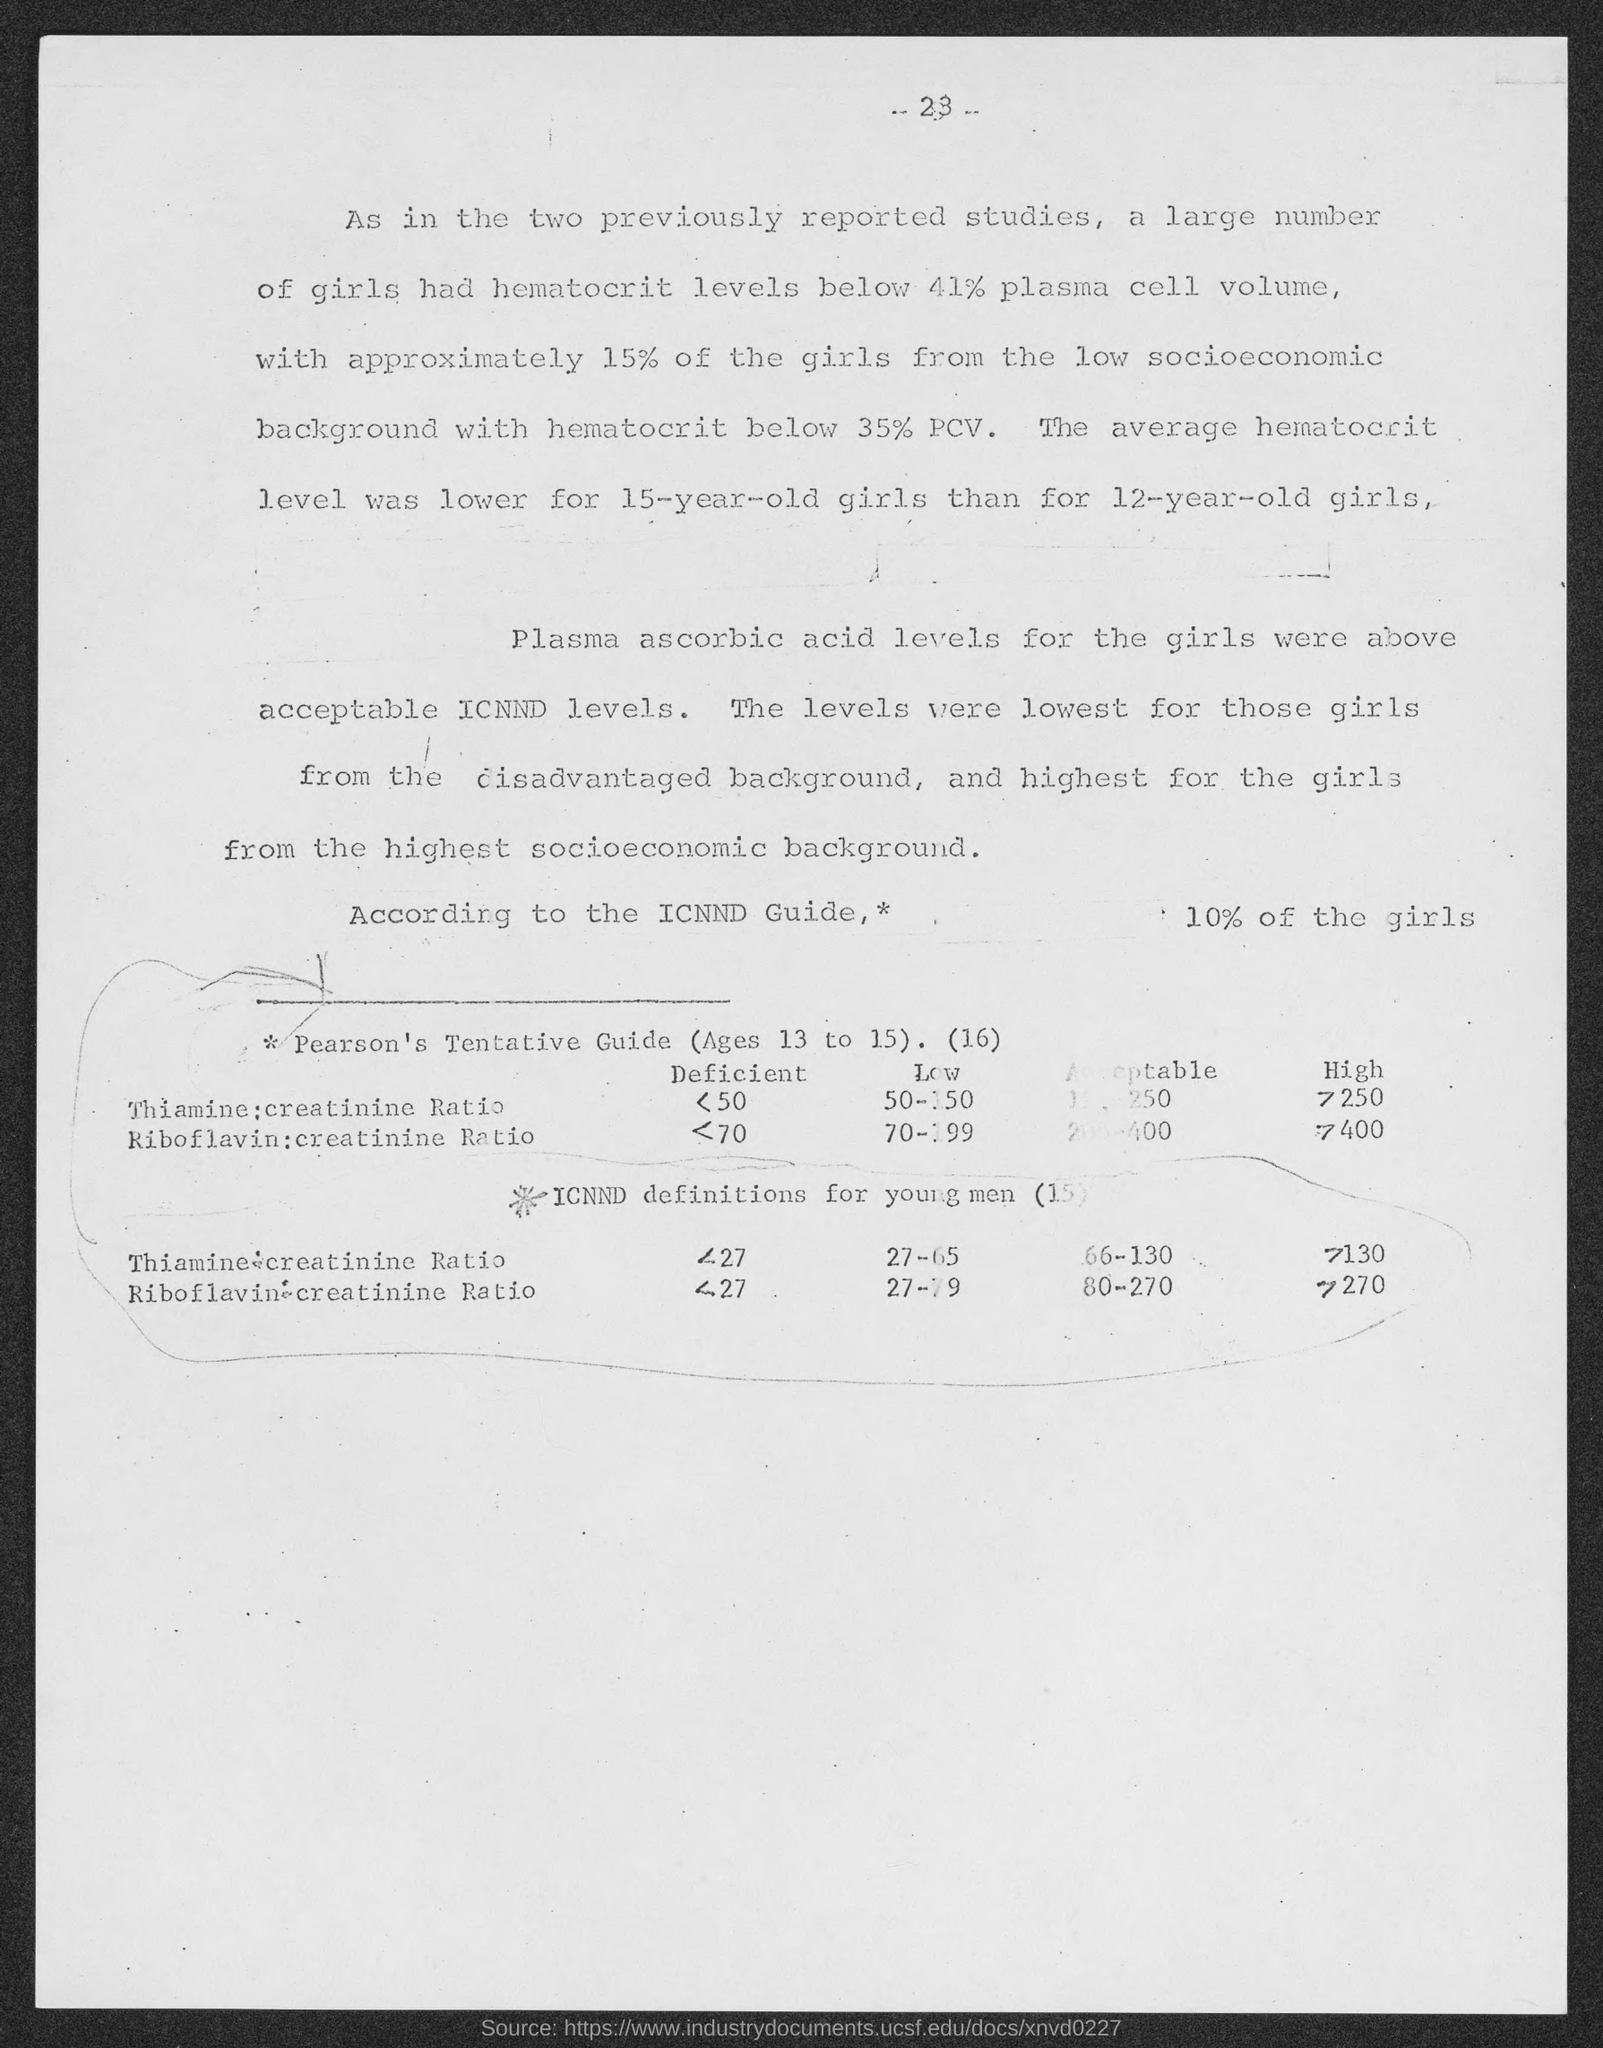Mention a couple of crucial points in this snapshot. The page number at the top of the page is 23. 